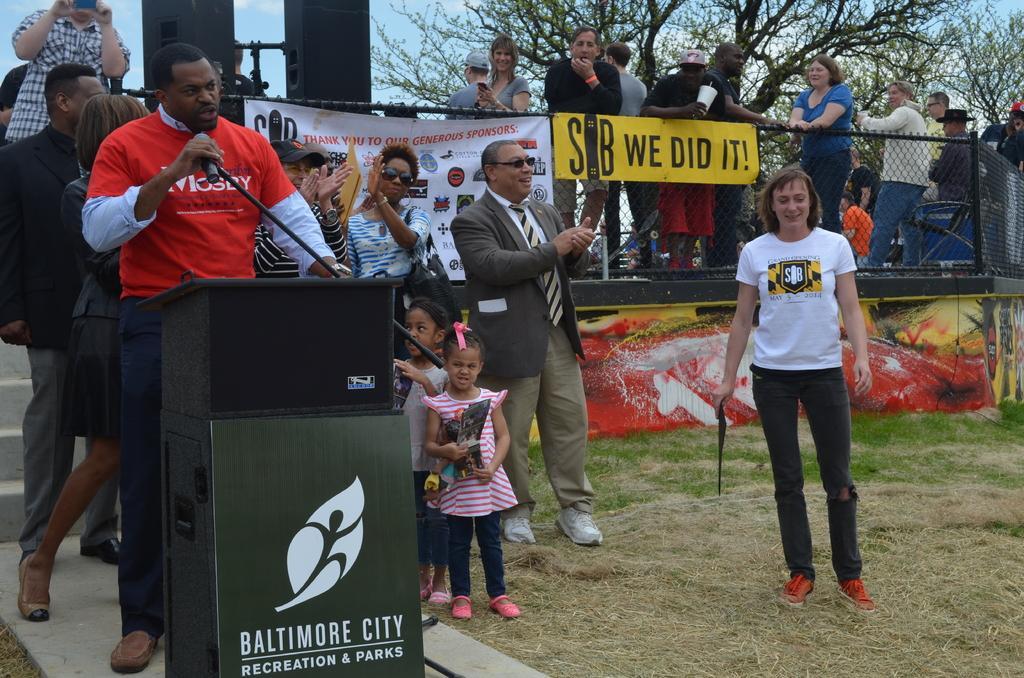How would you summarize this image in a sentence or two? In this image we can see some persons standing on ground and some are standing behind fencing to which there are some banners attached, in the foreground of the image there is a person wearing red color T-shirt standing behind wooden podium on which there is microphone and in the background of the image there are some sound boxes and trees. 